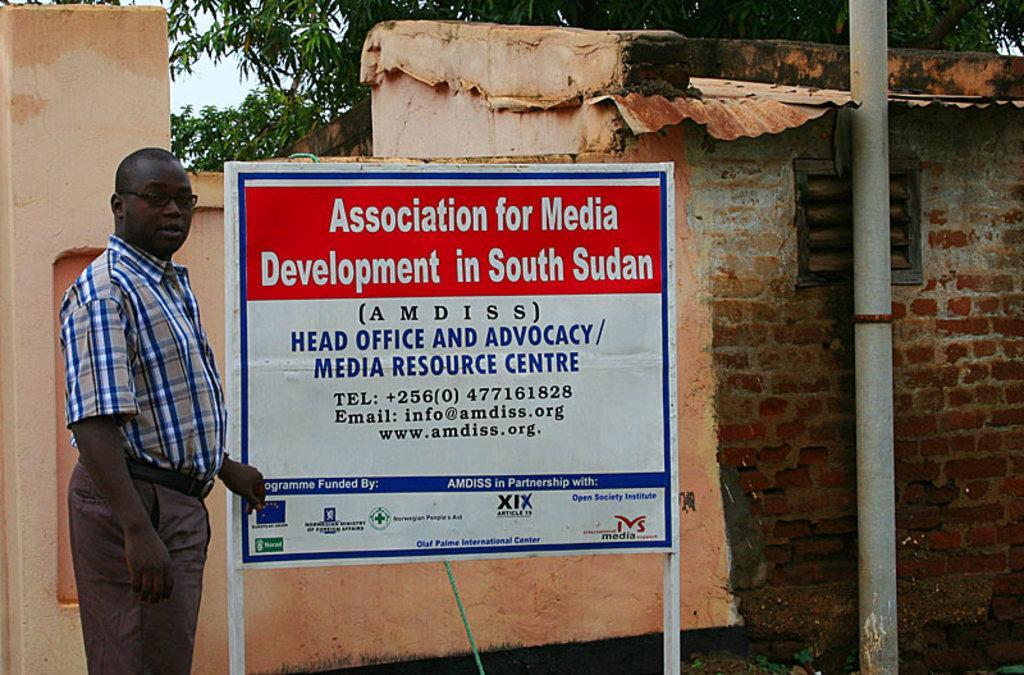Please provide a concise description of this image. There is a person standing near a notice board in the foreground area of the image, it seems like a house, pipe, trees and the sky in the background. 